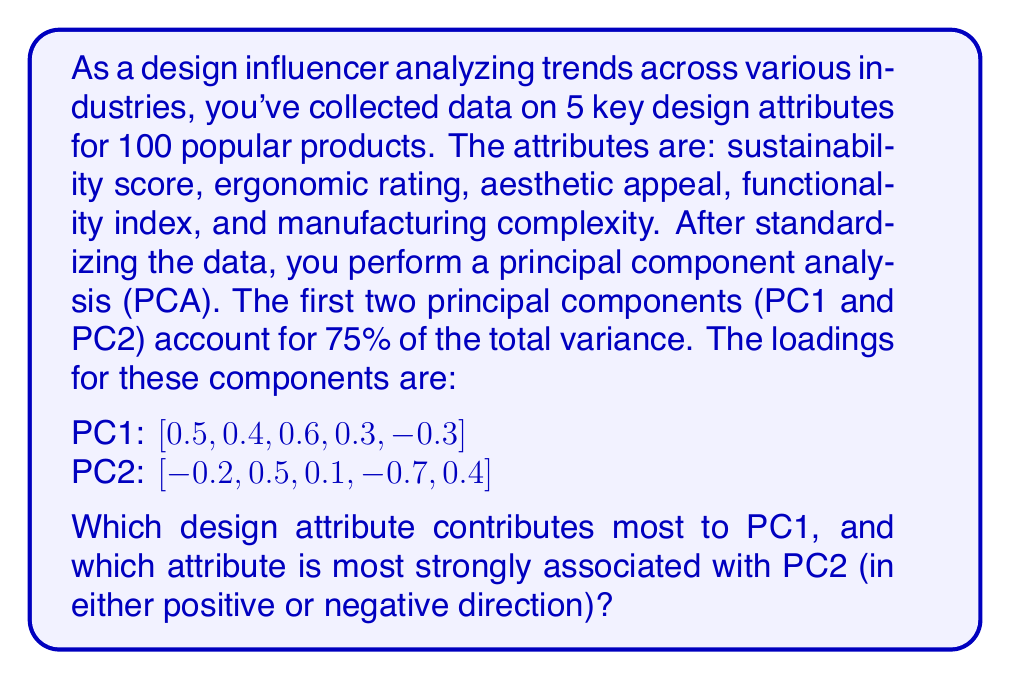Can you answer this question? To determine which design attribute contributes most to each principal component, we need to analyze the loadings for each component. The loadings represent the correlation between the original variables and the principal components.

For PC1:
1. Sustainability score: 0.5
2. Ergonomic rating: 0.4
3. Aesthetic appeal: 0.6
4. Functionality index: 0.3
5. Manufacturing complexity: -0.3

The largest absolute value is 0.6, corresponding to aesthetic appeal.

For PC2:
1. Sustainability score: -0.2
2. Ergonomic rating: 0.5
3. Aesthetic appeal: 0.1
4. Functionality index: -0.7
5. Manufacturing complexity: 0.4

The largest absolute value is 0.7, corresponding to functionality index.

The sign of the loading indicates the direction of the relationship:
- For PC1, aesthetic appeal has a positive loading, meaning it's positively correlated with PC1.
- For PC2, functionality index has a negative loading, meaning it's negatively correlated with PC2.

However, the question asks for the attribute most strongly associated with PC2 in either positive or negative direction, so we consider the absolute value.
Answer: Aesthetic appeal contributes most to PC1, and functionality index is most strongly associated with PC2. 